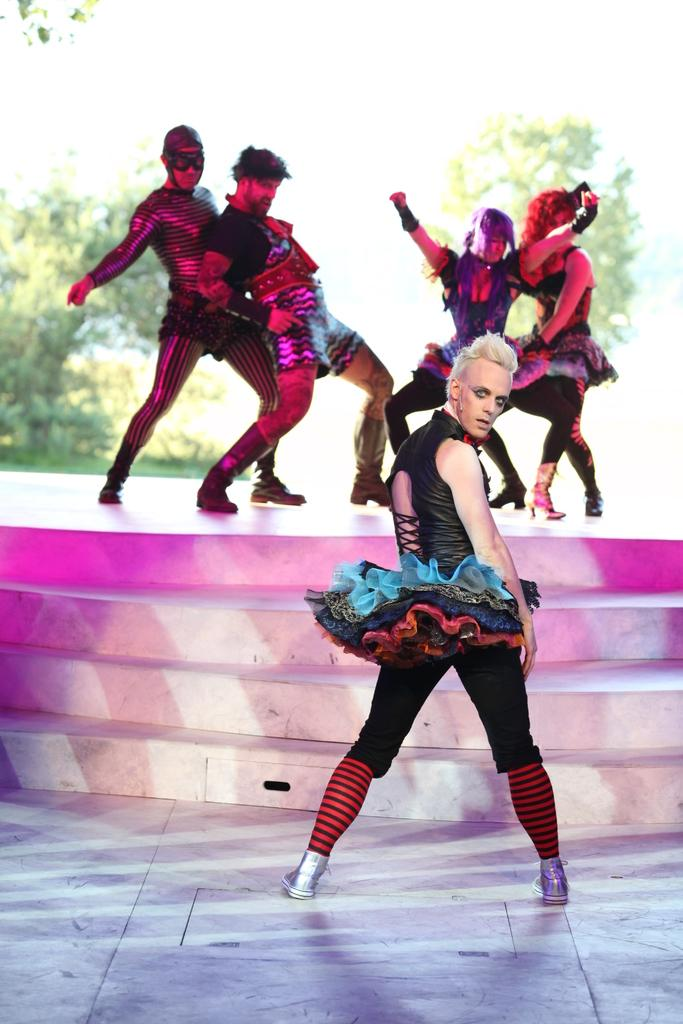What are the people in the image wearing? The people in the image are wearing costumes. What architectural feature can be seen in the image? There are stairs in the image. What can be seen in the background of the image? There are trees in the background of the image. What grade level is the school depicted in the image? There is no school or grade level present in the image; it features people wearing costumes and stairs. How many snakes can be seen slithering on the stairs in the image? There are no snakes present in the image; it features people wearing costumes and stairs. 